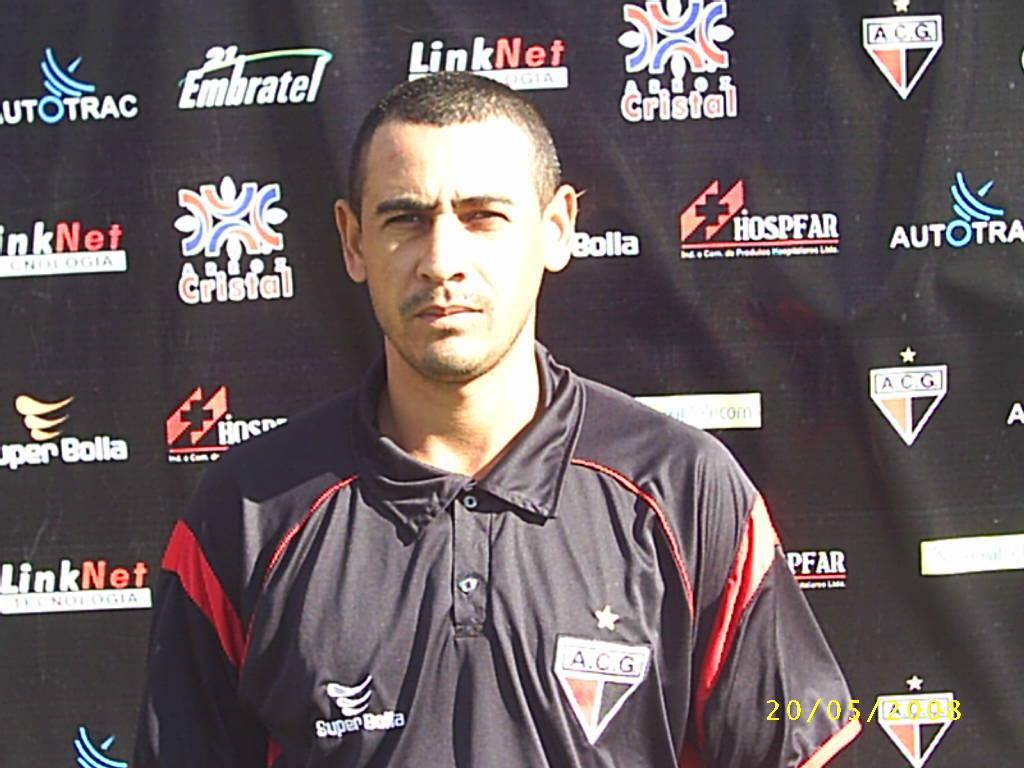<image>
Provide a brief description of the given image. a sports man in a ACG jersey standing in front of ads for places like Hospfar 